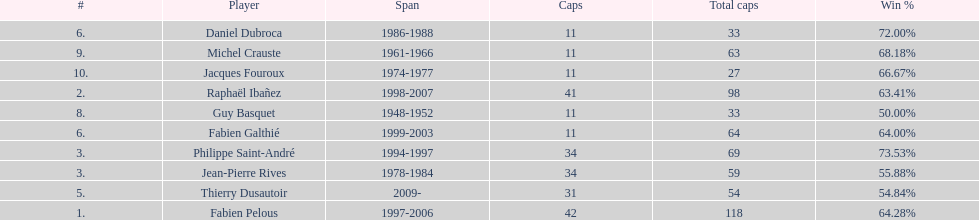How many caps did jean-pierre rives and michel crauste accrue? 122. 